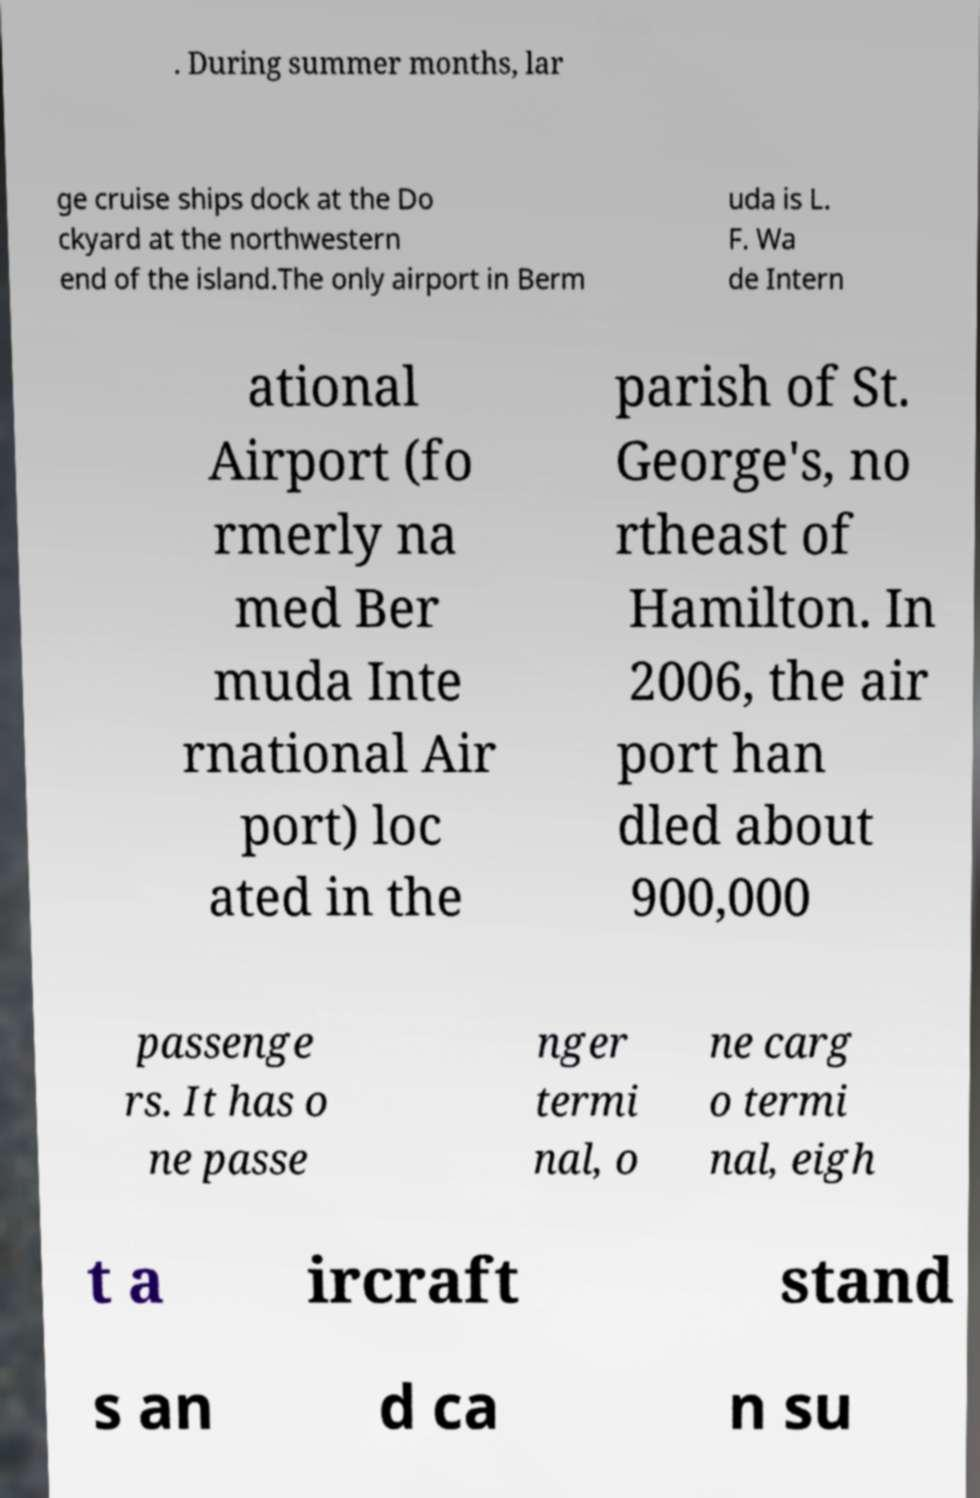I need the written content from this picture converted into text. Can you do that? . During summer months, lar ge cruise ships dock at the Do ckyard at the northwestern end of the island.The only airport in Berm uda is L. F. Wa de Intern ational Airport (fo rmerly na med Ber muda Inte rnational Air port) loc ated in the parish of St. George's, no rtheast of Hamilton. In 2006, the air port han dled about 900,000 passenge rs. It has o ne passe nger termi nal, o ne carg o termi nal, eigh t a ircraft stand s an d ca n su 